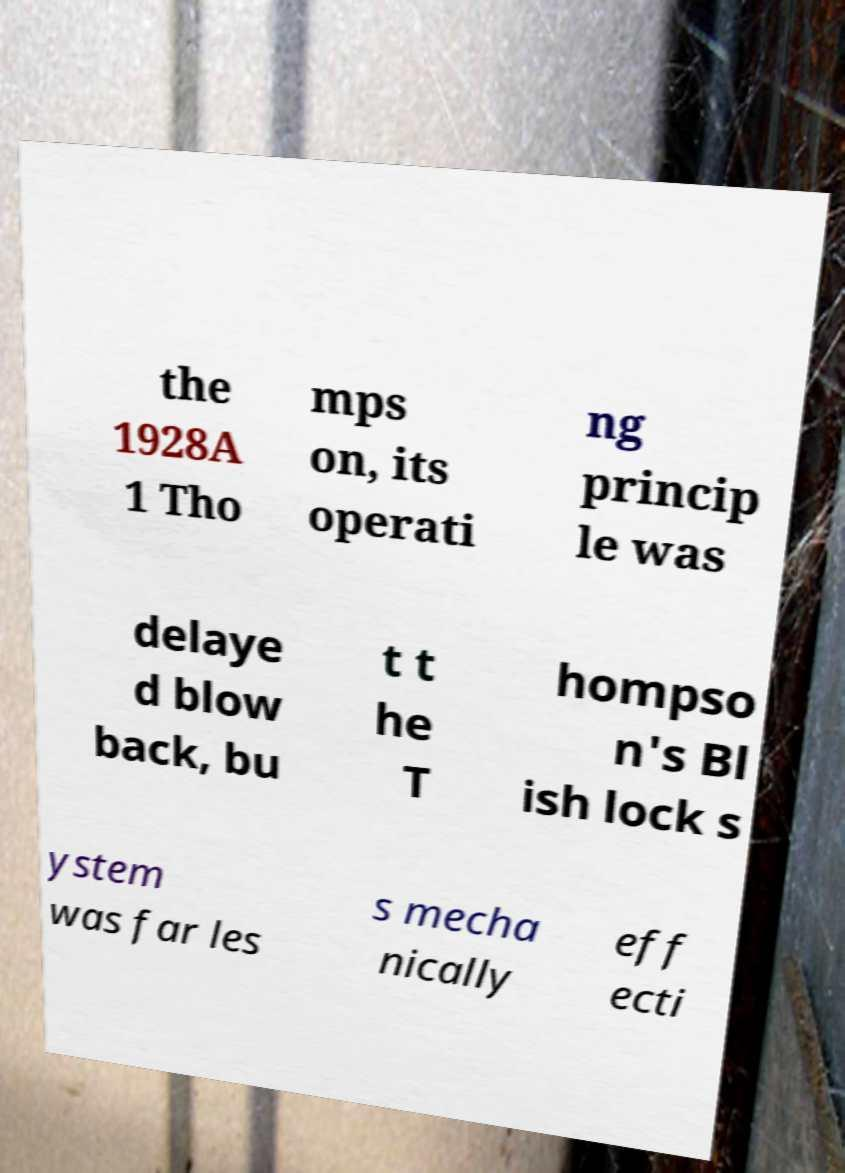Please read and relay the text visible in this image. What does it say? the 1928A 1 Tho mps on, its operati ng princip le was delaye d blow back, bu t t he T hompso n's Bl ish lock s ystem was far les s mecha nically eff ecti 